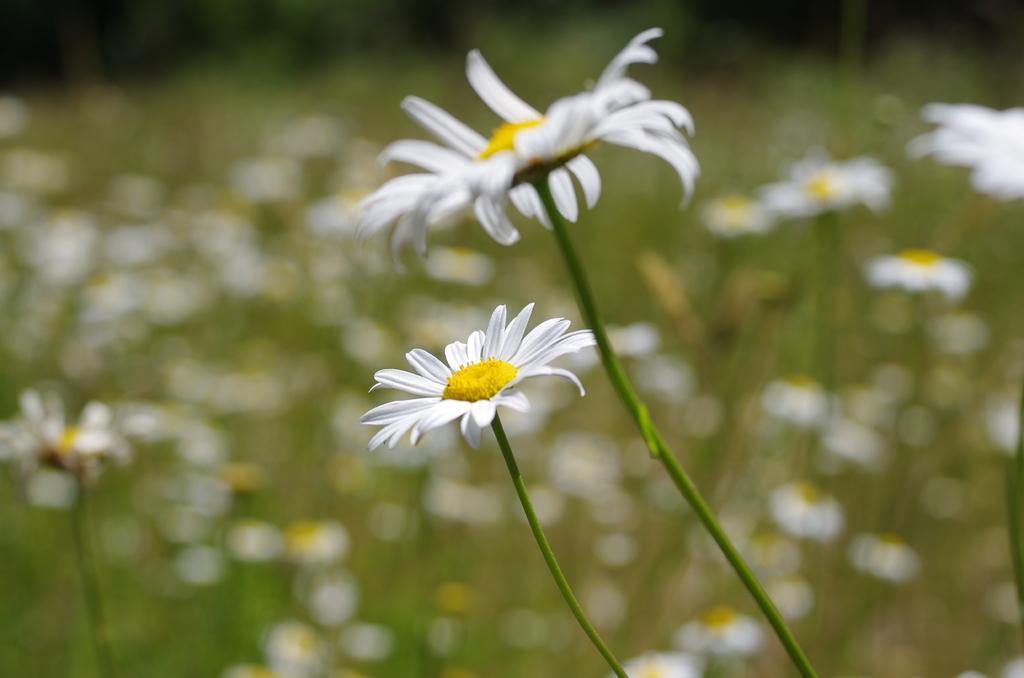Please provide a concise description of this image. In this picture we can see stems with flowers and in the background we can see flowers and it is blurry. 